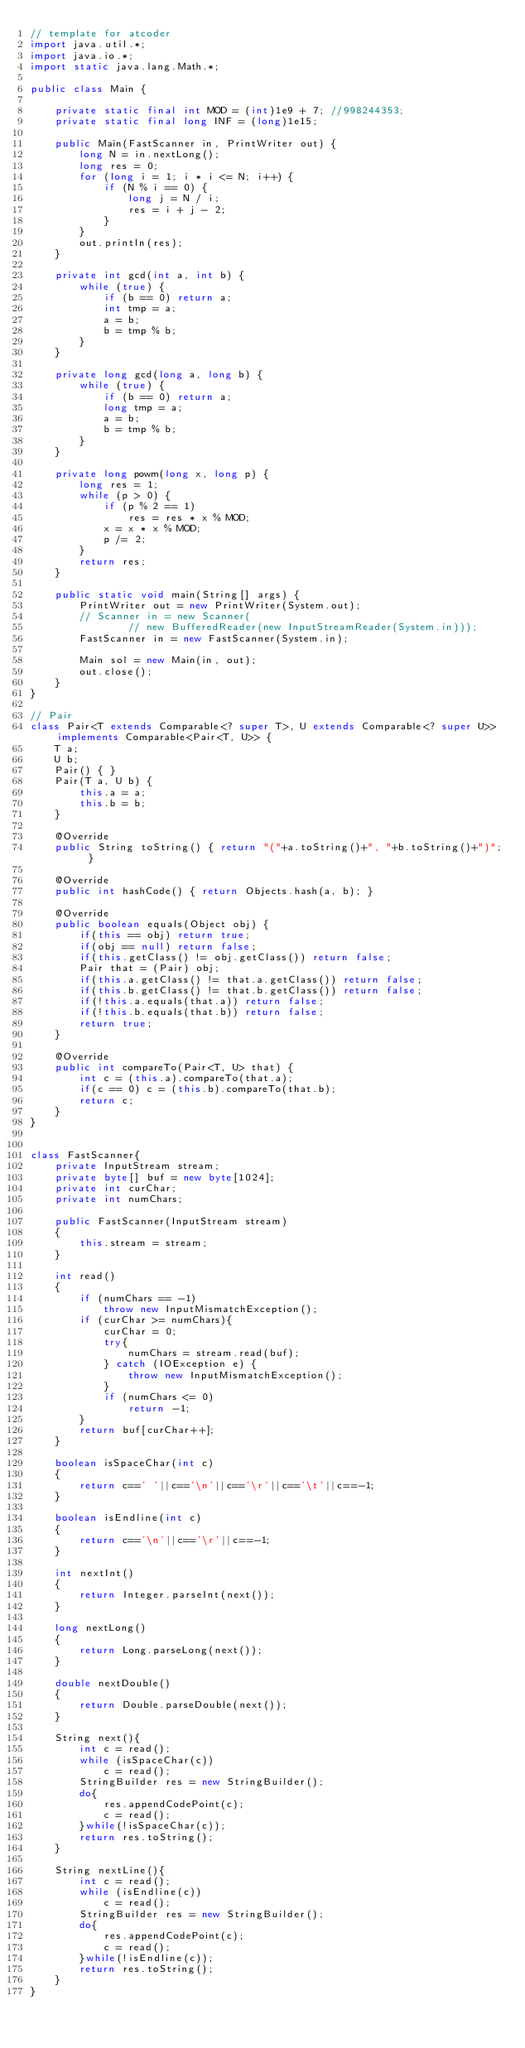<code> <loc_0><loc_0><loc_500><loc_500><_Java_>// template for atcoder
import java.util.*;
import java.io.*;
import static java.lang.Math.*;

public class Main {

    private static final int MOD = (int)1e9 + 7; //998244353;
    private static final long INF = (long)1e15;

    public Main(FastScanner in, PrintWriter out) {
        long N = in.nextLong();
        long res = 0;
        for (long i = 1; i * i <= N; i++) {
            if (N % i == 0) {
                long j = N / i;
                res = i + j - 2;
            }
        }
        out.println(res);
    }

    private int gcd(int a, int b) {
        while (true) {
            if (b == 0) return a;
            int tmp = a;
            a = b;
            b = tmp % b;
        }
    }

    private long gcd(long a, long b) {
        while (true) {
            if (b == 0) return a;
            long tmp = a;
            a = b;
            b = tmp % b;
        }
    }

    private long powm(long x, long p) {
        long res = 1;
        while (p > 0) {
            if (p % 2 == 1)
                res = res * x % MOD;
            x = x * x % MOD;
            p /= 2;
        }
        return res;
    }

    public static void main(String[] args) {
        PrintWriter out = new PrintWriter(System.out);
        // Scanner in = new Scanner(
                // new BufferedReader(new InputStreamReader(System.in)));
        FastScanner in = new FastScanner(System.in);

        Main sol = new Main(in, out);
        out.close();
    }
}

// Pair
class Pair<T extends Comparable<? super T>, U extends Comparable<? super U>> implements Comparable<Pair<T, U>> {
    T a;
    U b;
    Pair() { }
    Pair(T a, U b) {
        this.a = a;
        this.b = b;
    }

    @Override
    public String toString() { return "("+a.toString()+", "+b.toString()+")"; }

    @Override
    public int hashCode() { return Objects.hash(a, b); }

    @Override
    public boolean equals(Object obj) {
        if(this == obj) return true;
        if(obj == null) return false;
        if(this.getClass() != obj.getClass()) return false;
        Pair that = (Pair) obj;
        if(this.a.getClass() != that.a.getClass()) return false;
        if(this.b.getClass() != that.b.getClass()) return false;
        if(!this.a.equals(that.a)) return false;
        if(!this.b.equals(that.b)) return false;
        return true;
    }

    @Override
    public int compareTo(Pair<T, U> that) {
        int c = (this.a).compareTo(that.a);
        if(c == 0) c = (this.b).compareTo(that.b);
        return c;
    }
}


class FastScanner{
    private InputStream stream;
    private byte[] buf = new byte[1024];
    private int curChar;
    private int numChars;

    public FastScanner(InputStream stream)
    {
        this.stream = stream;
    }

    int read()
    {
        if (numChars == -1)
            throw new InputMismatchException();
        if (curChar >= numChars){
            curChar = 0;
            try{
                numChars = stream.read(buf);
            } catch (IOException e) {
                throw new InputMismatchException();
            }
            if (numChars <= 0)
                return -1;
        }
        return buf[curChar++];
    }

    boolean isSpaceChar(int c)
    {
        return c==' '||c=='\n'||c=='\r'||c=='\t'||c==-1;
    }

    boolean isEndline(int c)
    {
        return c=='\n'||c=='\r'||c==-1;
    }

    int nextInt()
    {
        return Integer.parseInt(next());
    }

    long nextLong()
    {
        return Long.parseLong(next());
    }

    double nextDouble()
    {
        return Double.parseDouble(next());
    }

    String next(){
        int c = read();
        while (isSpaceChar(c))
            c = read();
        StringBuilder res = new StringBuilder();
        do{
            res.appendCodePoint(c);
            c = read();
        }while(!isSpaceChar(c));
        return res.toString();
    }

    String nextLine(){
        int c = read();
        while (isEndline(c))
            c = read();
        StringBuilder res = new StringBuilder();
        do{
            res.appendCodePoint(c);
            c = read();
        }while(!isEndline(c));
        return res.toString();
    }
}
</code> 